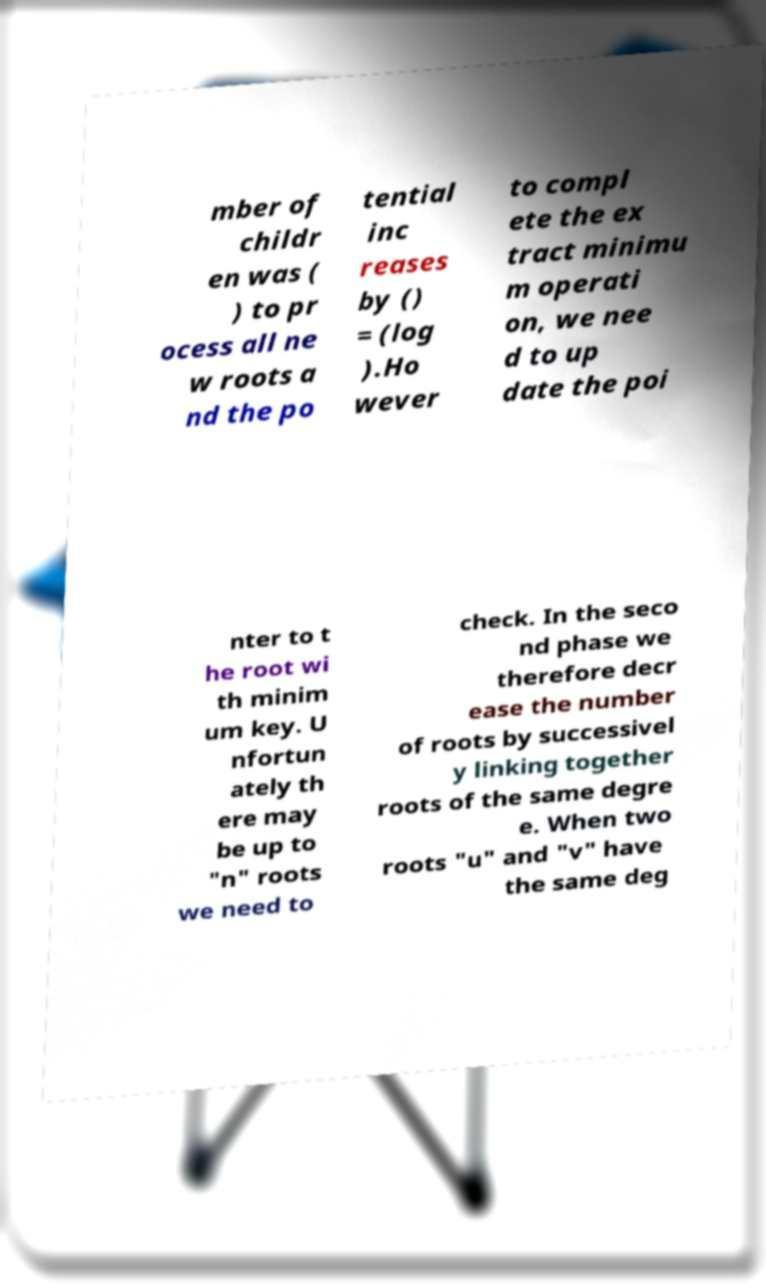Could you assist in decoding the text presented in this image and type it out clearly? mber of childr en was ( ) to pr ocess all ne w roots a nd the po tential inc reases by () = (log ).Ho wever to compl ete the ex tract minimu m operati on, we nee d to up date the poi nter to t he root wi th minim um key. U nfortun ately th ere may be up to "n" roots we need to check. In the seco nd phase we therefore decr ease the number of roots by successivel y linking together roots of the same degre e. When two roots "u" and "v" have the same deg 